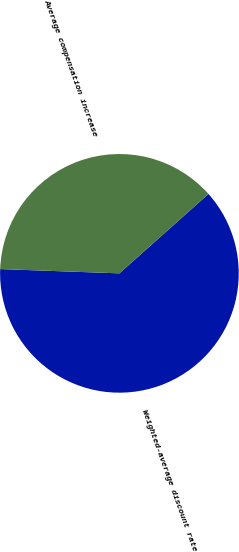Convert chart. <chart><loc_0><loc_0><loc_500><loc_500><pie_chart><fcel>Weighted-average discount rate<fcel>Average compensation increase<nl><fcel>62.16%<fcel>37.84%<nl></chart> 